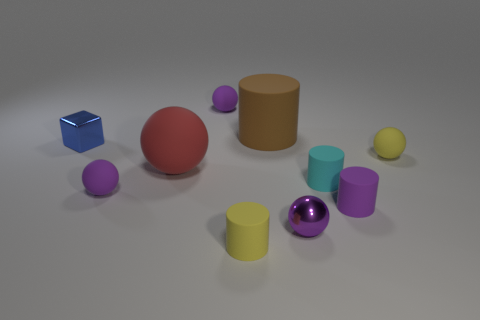Subtract all tiny spheres. How many spheres are left? 1 Subtract all green blocks. How many purple spheres are left? 3 Subtract 1 balls. How many balls are left? 4 Subtract all yellow balls. How many balls are left? 4 Subtract all cylinders. How many objects are left? 6 Subtract all brown balls. Subtract all brown blocks. How many balls are left? 5 Subtract 0 green spheres. How many objects are left? 10 Subtract all brown cylinders. Subtract all tiny rubber cylinders. How many objects are left? 6 Add 4 tiny purple shiny balls. How many tiny purple shiny balls are left? 5 Add 3 tiny green shiny cylinders. How many tiny green shiny cylinders exist? 3 